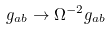Convert formula to latex. <formula><loc_0><loc_0><loc_500><loc_500>g _ { a b } \rightarrow \Omega ^ { - 2 } g _ { a b }</formula> 